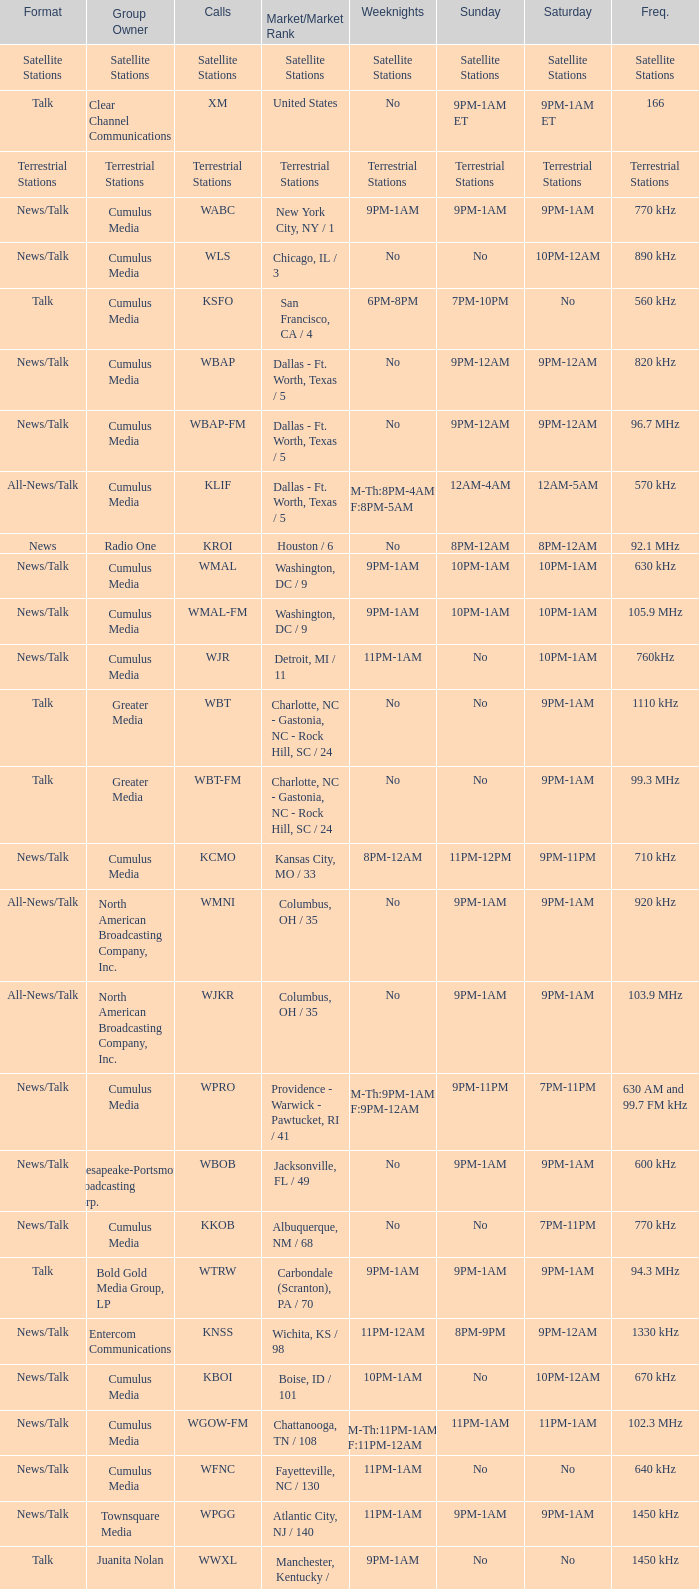What is the market for the 11pm-1am Saturday game? Chattanooga, TN / 108. 